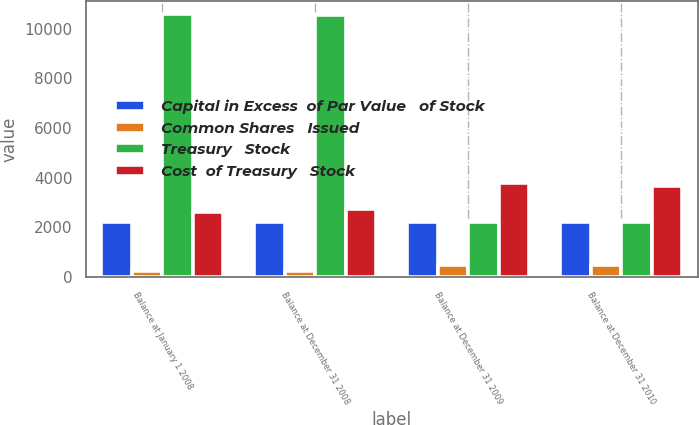Convert chart to OTSL. <chart><loc_0><loc_0><loc_500><loc_500><stacked_bar_chart><ecel><fcel>Balance at January 1 2008<fcel>Balance at December 31 2008<fcel>Balance at December 31 2009<fcel>Balance at December 31 2010<nl><fcel>Capital in Excess  of Par Value   of Stock<fcel>2205<fcel>2205<fcel>2205<fcel>2205<nl><fcel>Common Shares   Issued<fcel>226<fcel>226<fcel>491<fcel>501<nl><fcel>Treasury   Stock<fcel>10584<fcel>10566<fcel>2205<fcel>2205<nl><fcel>Cost  of Treasury   Stock<fcel>2625<fcel>2757<fcel>3768<fcel>3682<nl></chart> 